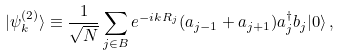<formula> <loc_0><loc_0><loc_500><loc_500>| \psi _ { k } ^ { ( 2 ) } \rangle \equiv \frac { 1 } { \sqrt { N } } \sum _ { j \in B } e ^ { - i k R _ { j } } ( a _ { j - 1 } + a _ { j + 1 } ) a _ { j } ^ { \dagger } b _ { j } | 0 \rangle \, ,</formula> 